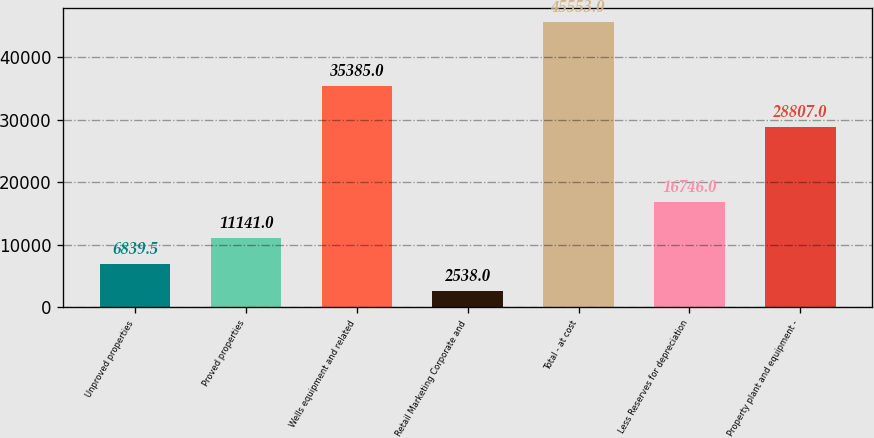Convert chart to OTSL. <chart><loc_0><loc_0><loc_500><loc_500><bar_chart><fcel>Unproved properties<fcel>Proved properties<fcel>Wells equipment and related<fcel>Retail Marketing Corporate and<fcel>Total - at cost<fcel>Less Reserves for depreciation<fcel>Property plant and equipment -<nl><fcel>6839.5<fcel>11141<fcel>35385<fcel>2538<fcel>45553<fcel>16746<fcel>28807<nl></chart> 